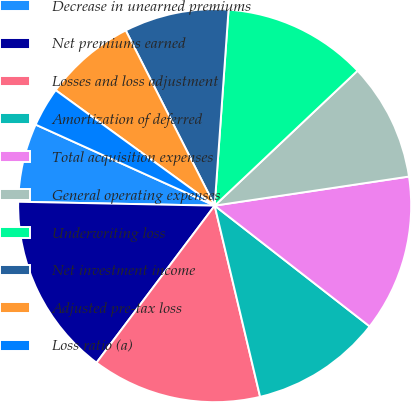Convert chart. <chart><loc_0><loc_0><loc_500><loc_500><pie_chart><fcel>Decrease in unearned premiums<fcel>Net premiums earned<fcel>Losses and loss adjustment<fcel>Amortization of deferred<fcel>Total acquisition expenses<fcel>General operating expenses<fcel>Underwriting loss<fcel>Net investment income<fcel>Adjusted pre-tax loss<fcel>Loss ratio (a)<nl><fcel>6.45%<fcel>15.05%<fcel>13.98%<fcel>10.75%<fcel>12.9%<fcel>9.68%<fcel>11.83%<fcel>8.6%<fcel>7.53%<fcel>3.23%<nl></chart> 